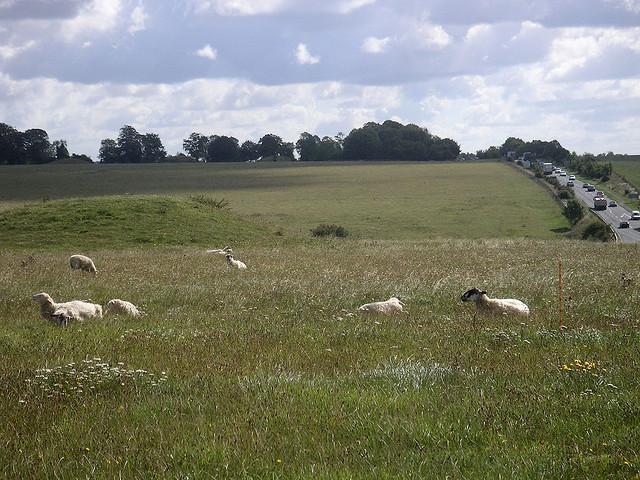How many sheep are in the pasture?
Give a very brief answer. 7. How many sheep are in the picture?
Give a very brief answer. 6. How many rocks are on the right?
Give a very brief answer. 0. How many animals can be seen?
Give a very brief answer. 7. How many animals are laying down?
Give a very brief answer. 6. How many white sheep are in this scene?
Give a very brief answer. 7. How many sheep?
Give a very brief answer. 6. How many birds are in this photo?
Give a very brief answer. 0. 